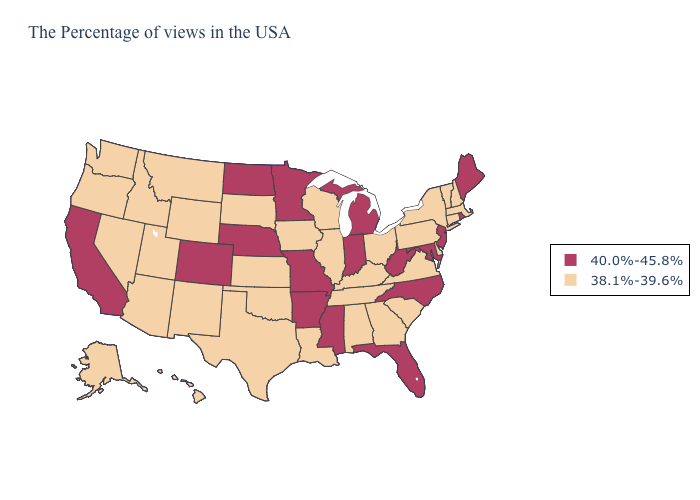Which states have the lowest value in the USA?
Keep it brief. Massachusetts, New Hampshire, Vermont, Connecticut, New York, Delaware, Pennsylvania, Virginia, South Carolina, Ohio, Georgia, Kentucky, Alabama, Tennessee, Wisconsin, Illinois, Louisiana, Iowa, Kansas, Oklahoma, Texas, South Dakota, Wyoming, New Mexico, Utah, Montana, Arizona, Idaho, Nevada, Washington, Oregon, Alaska, Hawaii. What is the lowest value in states that border West Virginia?
Concise answer only. 38.1%-39.6%. What is the lowest value in the USA?
Keep it brief. 38.1%-39.6%. Name the states that have a value in the range 40.0%-45.8%?
Keep it brief. Maine, Rhode Island, New Jersey, Maryland, North Carolina, West Virginia, Florida, Michigan, Indiana, Mississippi, Missouri, Arkansas, Minnesota, Nebraska, North Dakota, Colorado, California. What is the highest value in states that border Kansas?
Answer briefly. 40.0%-45.8%. Name the states that have a value in the range 40.0%-45.8%?
Concise answer only. Maine, Rhode Island, New Jersey, Maryland, North Carolina, West Virginia, Florida, Michigan, Indiana, Mississippi, Missouri, Arkansas, Minnesota, Nebraska, North Dakota, Colorado, California. Name the states that have a value in the range 38.1%-39.6%?
Answer briefly. Massachusetts, New Hampshire, Vermont, Connecticut, New York, Delaware, Pennsylvania, Virginia, South Carolina, Ohio, Georgia, Kentucky, Alabama, Tennessee, Wisconsin, Illinois, Louisiana, Iowa, Kansas, Oklahoma, Texas, South Dakota, Wyoming, New Mexico, Utah, Montana, Arizona, Idaho, Nevada, Washington, Oregon, Alaska, Hawaii. Does New Hampshire have a lower value than Nebraska?
Quick response, please. Yes. Which states have the lowest value in the USA?
Quick response, please. Massachusetts, New Hampshire, Vermont, Connecticut, New York, Delaware, Pennsylvania, Virginia, South Carolina, Ohio, Georgia, Kentucky, Alabama, Tennessee, Wisconsin, Illinois, Louisiana, Iowa, Kansas, Oklahoma, Texas, South Dakota, Wyoming, New Mexico, Utah, Montana, Arizona, Idaho, Nevada, Washington, Oregon, Alaska, Hawaii. Which states have the highest value in the USA?
Be succinct. Maine, Rhode Island, New Jersey, Maryland, North Carolina, West Virginia, Florida, Michigan, Indiana, Mississippi, Missouri, Arkansas, Minnesota, Nebraska, North Dakota, Colorado, California. Name the states that have a value in the range 38.1%-39.6%?
Quick response, please. Massachusetts, New Hampshire, Vermont, Connecticut, New York, Delaware, Pennsylvania, Virginia, South Carolina, Ohio, Georgia, Kentucky, Alabama, Tennessee, Wisconsin, Illinois, Louisiana, Iowa, Kansas, Oklahoma, Texas, South Dakota, Wyoming, New Mexico, Utah, Montana, Arizona, Idaho, Nevada, Washington, Oregon, Alaska, Hawaii. Is the legend a continuous bar?
Keep it brief. No. Does Nevada have a lower value than Louisiana?
Concise answer only. No. What is the value of Arkansas?
Give a very brief answer. 40.0%-45.8%. Name the states that have a value in the range 38.1%-39.6%?
Give a very brief answer. Massachusetts, New Hampshire, Vermont, Connecticut, New York, Delaware, Pennsylvania, Virginia, South Carolina, Ohio, Georgia, Kentucky, Alabama, Tennessee, Wisconsin, Illinois, Louisiana, Iowa, Kansas, Oklahoma, Texas, South Dakota, Wyoming, New Mexico, Utah, Montana, Arizona, Idaho, Nevada, Washington, Oregon, Alaska, Hawaii. 